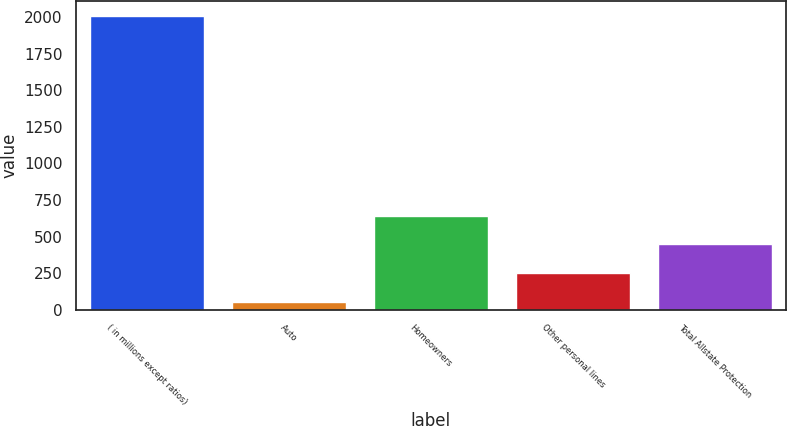Convert chart to OTSL. <chart><loc_0><loc_0><loc_500><loc_500><bar_chart><fcel>( in millions except ratios)<fcel>Auto<fcel>Homeowners<fcel>Other personal lines<fcel>Total Allstate Protection<nl><fcel>2009<fcel>57<fcel>642.6<fcel>252.2<fcel>447.4<nl></chart> 